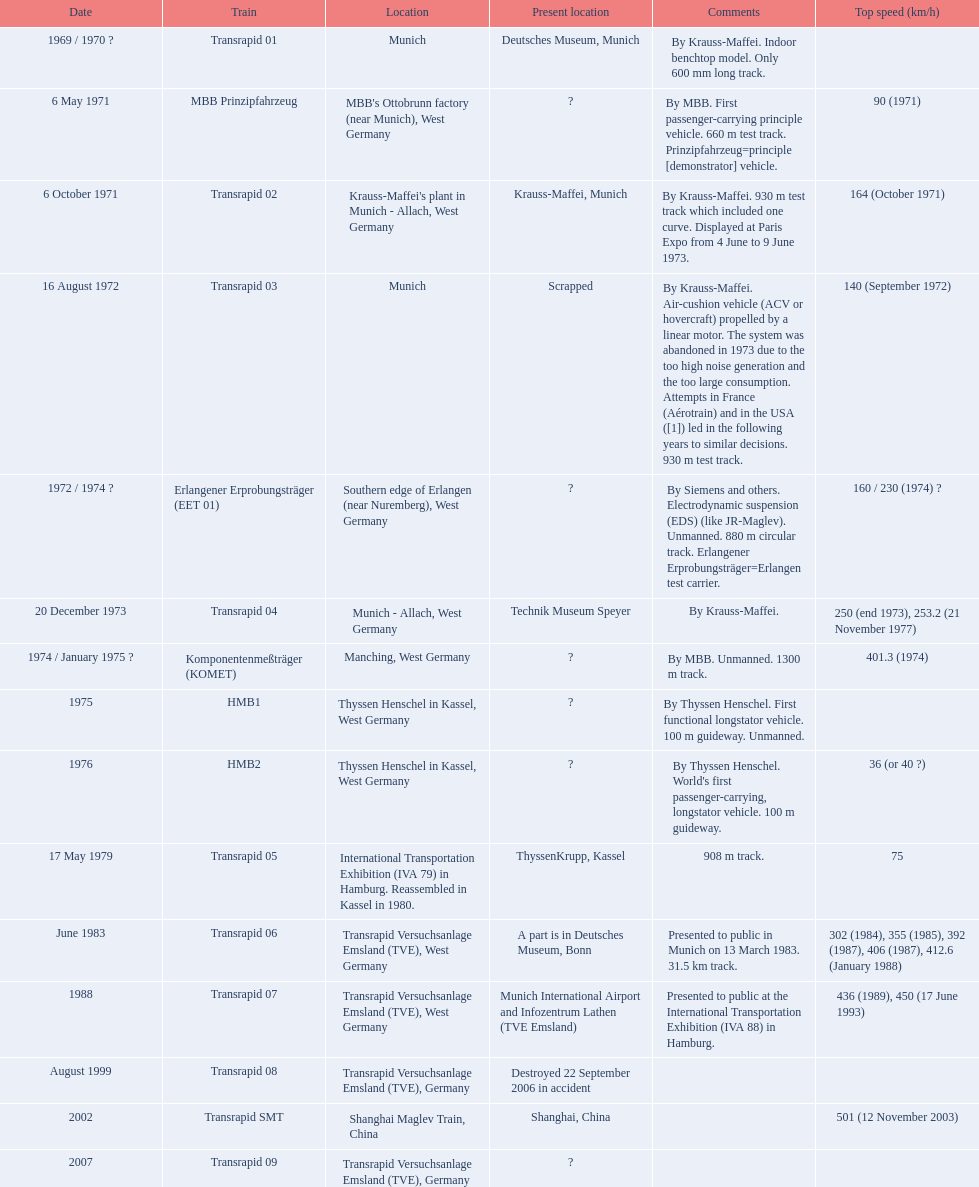What are all the trains? Transrapid 01, MBB Prinzipfahrzeug, Transrapid 02, Transrapid 03, Erlangener Erprobungsträger (EET 01), Transrapid 04, Komponentenmeßträger (KOMET), HMB1, HMB2, Transrapid 05, Transrapid 06, Transrapid 07, Transrapid 08, Transrapid SMT, Transrapid 09. Which of all the train positions are recognized? Deutsches Museum, Munich, Krauss-Maffei, Munich, Scrapped, Technik Museum Speyer, ThyssenKrupp, Kassel, A part is in Deutsches Museum, Bonn, Munich International Airport and Infozentrum Lathen (TVE Emsland), Destroyed 22 September 2006 in accident, Shanghai, China. Which of those trains were discarded? Transrapid 03. 